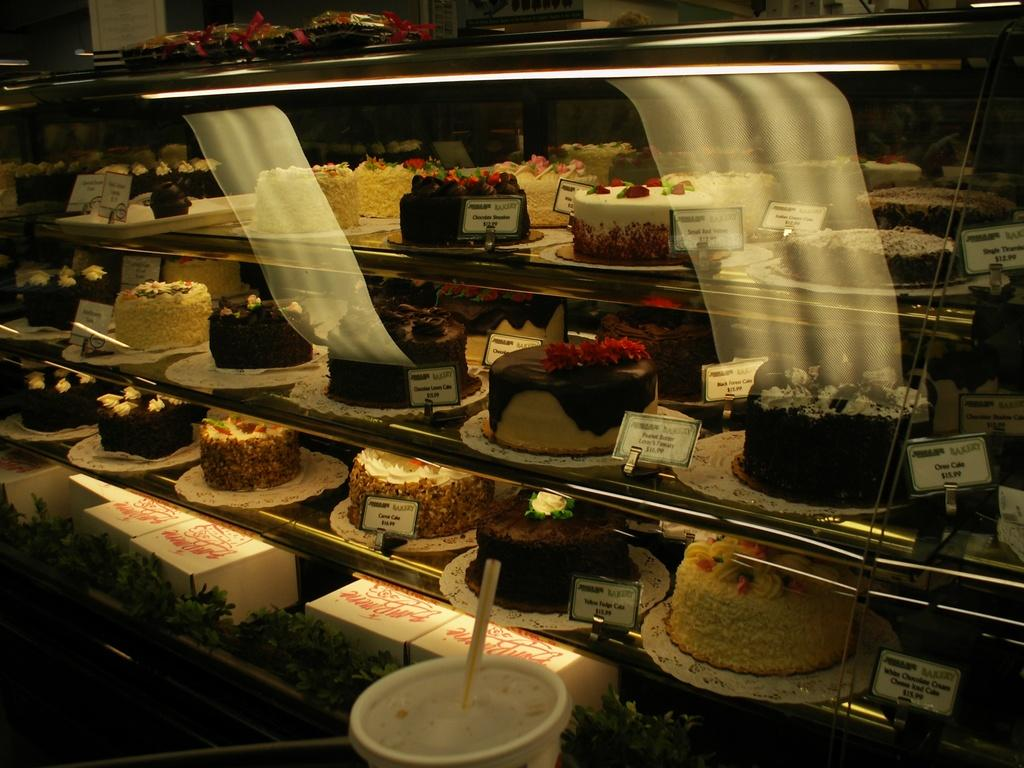What is the main structure in the image? There is a rack in the image. What items can be found on the rack? The rack contains cakes, boxes, and boards with text. How many objects are on the rack? There are multiple objects on the rack. Is there any beverage-related item in the image? Yes, there is a cup with a straw in the image. What type of yarn is being used to create the canvas in the image? There is no canvas or yarn present in the image. What mode of transportation is being used for the voyage in the image? There is no voyage or transportation depicted in the image. 